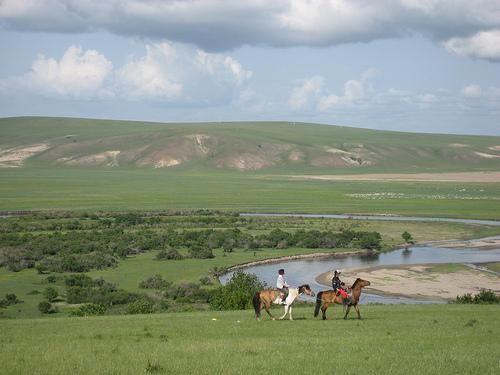What word would best describe their movement?

Choices:
A) gallop
B) skip
C) walk
D) sprint walk 